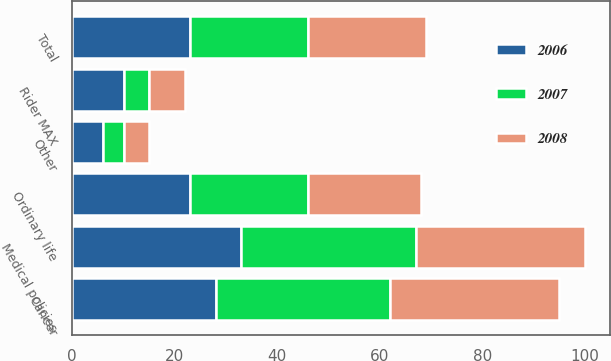<chart> <loc_0><loc_0><loc_500><loc_500><stacked_bar_chart><ecel><fcel>Medical policies<fcel>Cancer<fcel>Ordinary life<fcel>Rider MAX<fcel>Other<fcel>Total<nl><fcel>2007<fcel>34<fcel>34<fcel>23<fcel>5<fcel>4<fcel>23<nl><fcel>2008<fcel>33<fcel>33<fcel>22<fcel>7<fcel>5<fcel>23<nl><fcel>2006<fcel>33<fcel>28<fcel>23<fcel>10<fcel>6<fcel>23<nl></chart> 